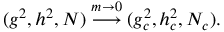<formula> <loc_0><loc_0><loc_500><loc_500>( g ^ { 2 } , h ^ { 2 } , N ) \stackrel { m \rightarrow 0 } { \longrightarrow } ( g _ { c } ^ { 2 } , h _ { c } ^ { 2 } , N _ { c } ) .</formula> 